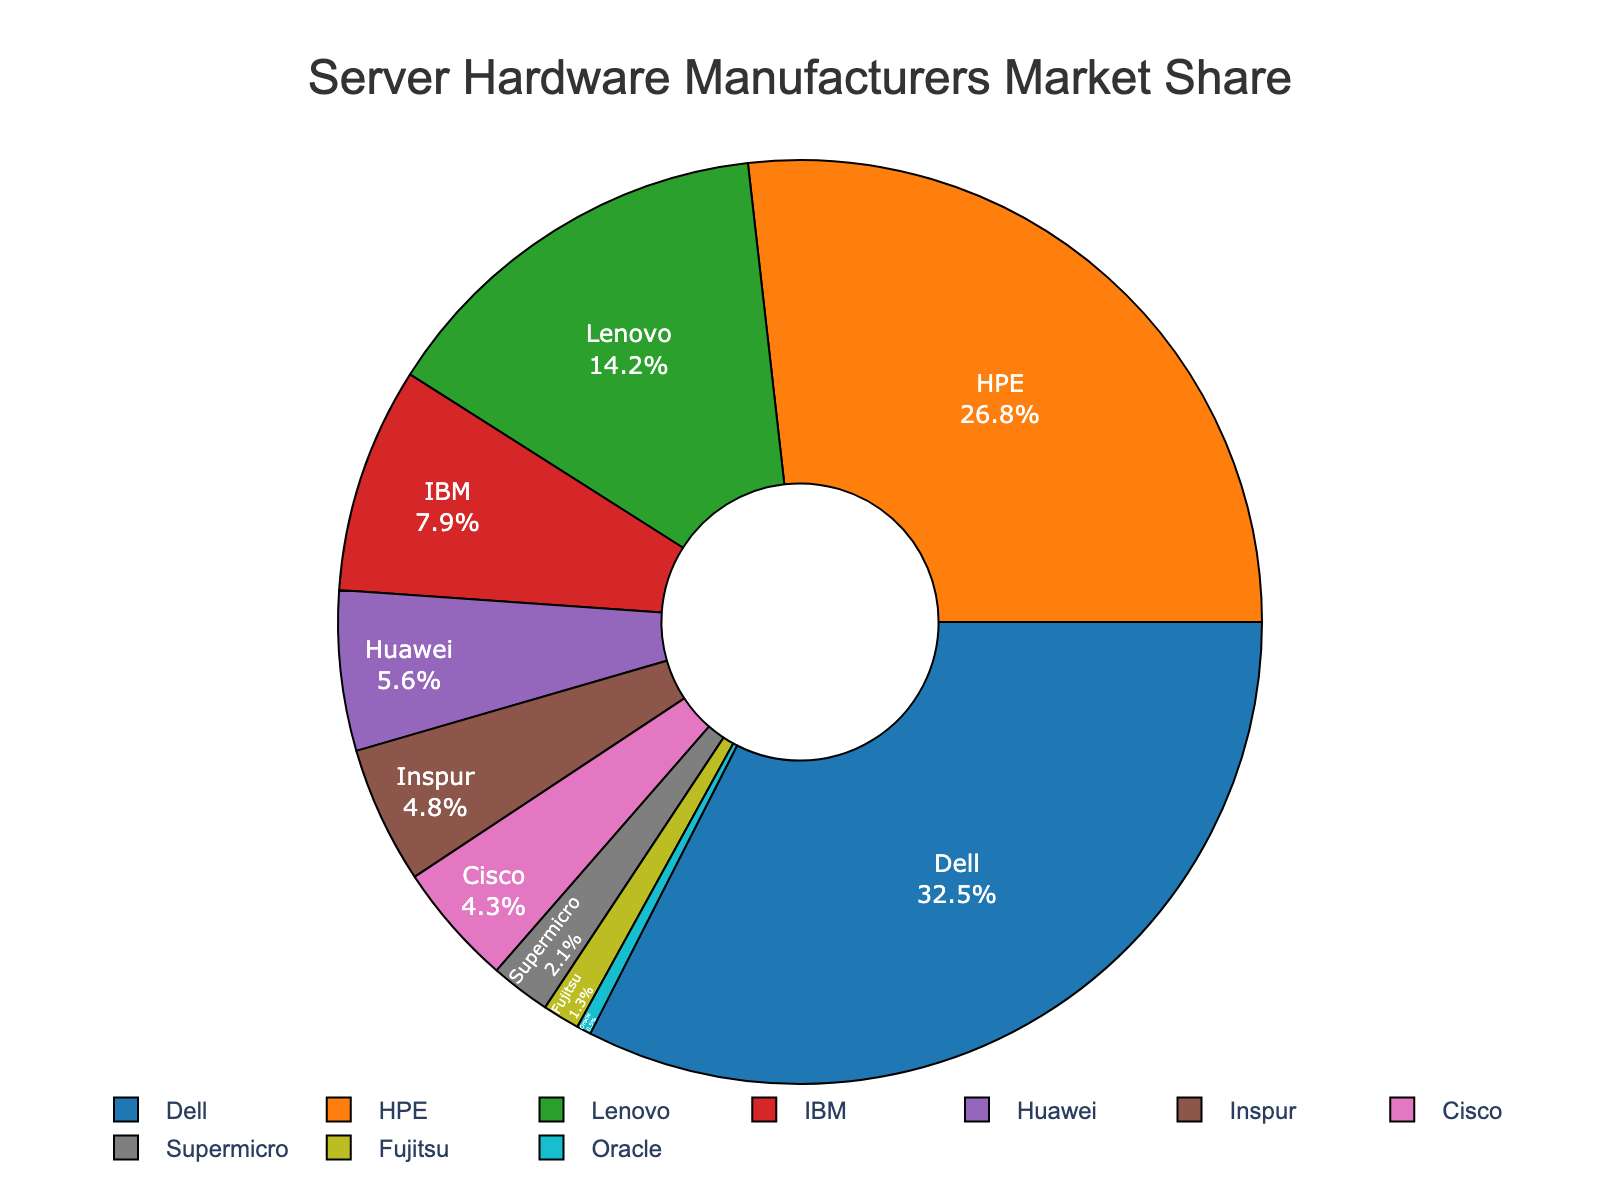What is the market share of the top three server hardware manufacturers combined? To determine this, we need to sum the market shares of Dell (32.5%), HPE (26.8%), and Lenovo (14.2%). 32.5 + 26.8 + 14.2 = 73.5. Therefore, the combined market share of the top three manufacturers is 73.5%.
Answer: 73.5% Which manufacturer has the smallest market share, and what is its percentage? By looking at the pie chart, we can identify the segment with the smallest percentage, which is Oracle. Oracle has a market share of 0.5%.
Answer: Oracle, 0.5% How much higher is Dell's market share than IBM's? Dell has a market share of 32.5%, while IBM has 7.9%. To find the difference, we subtract IBM's share from Dell's: 32.5 - 7.9 = 24.6. Therefore, Dell's market share is 24.6% higher than IBM's.
Answer: 24.6% What is the total market share of manufacturers with less than 5% share each? The manufacturers with less than 5% share are Huawei (5.6% excluded), Inspur (4.8%), Cisco (4.3%), Supermicro (2.1%), Fujitsu (1.3%), and Oracle (0.5%). Summing their shares: 4.8 + 4.3 + 2.1 + 1.3 + 0.5 = 13.
Answer: 13% What is the difference between the market share of Dell and the combined market share of Huawei, Inspur, Cisco, and Supermicro? Dell's market share is 32.5%. The combined market share of Huawei (5.6%), Inspur (4.8%), Cisco (4.3%), and Supermicro (2.1%) is 5.6 + 4.8 + 4.3 + 2.1 = 16.8%. The difference is 32.5 - 16.8 = 15.7.
Answer: 15.7% Which manufacturer holds a market share closer to the average market share of all manufacturers? First, we calculate the average market share by summing all the shares and dividing by the number of manufacturers: (32.5 + 26.8 + 14.2 + 7.9 + 5.6 + 4.8 + 4.3 + 2.1 + 1.3 + 0.5) / 10 = 10.4. Fujitsu has a market share of 1.3%, which is closest to the average.
Answer: Fujitsu What percentage of the market is held by manufacturers other than Dell and HPE? The total market share without Dell (32.5%) and HPE (26.8%) is calculated by subtracting their combined share from 100%. Combined share of Dell and HPE is 32.5 + 26.8 = 59.3. Therefore, the market share of other manufacturers is 100 - 59.3 = 40.7%.
Answer: 40.7% Which manufacturer has a market share that is more than twice that of Oracle? Oracle holds 0.5% of the market. A manufacturer whose market share is more than twice this would need more than 1.0%. All manufacturers except Oracle itself (0.5%) have more than twice the market share of Oracle.
Answer: All except Oracle What is the combined market share of the bottom five manufacturers? The bottom five manufacturers in terms of market share are Cisco (4.3%), Supermicro (2.1%), Fujitsu (1.3%), and Oracle (0.5%). Summing them: 4.3 + 2.1 + 1.3 + 0.5 = 8.2%.
Answer: 8.2% Which has a greater market share – the combination of Lenovo and Huawei or that of IBM and Inspur? Lenovo's market share is 14.2% and Huawei's is 5.6%, giving a combined share of 14.2 + 5.6 = 19.8%. IBM has a market share of 7.9% and Inspur has 4.8%, giving a combined share of 7.9 + 4.8 = 12.7%. Therefore, Lenovo and Huawei together have a greater market share than IBM and Inspur together.
Answer: Lenovo and Huawei 